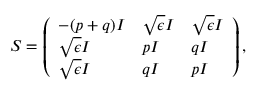<formula> <loc_0><loc_0><loc_500><loc_500>S = \left ( \begin{array} { l l l } { - ( p + q ) I } & { \sqrt { \epsilon } I } & { \sqrt { \epsilon } I } \\ { \sqrt { \epsilon } I } & { p I } & { q I } \\ { \sqrt { \epsilon } I } & { q I } & { p I } \end{array} \right ) ,</formula> 